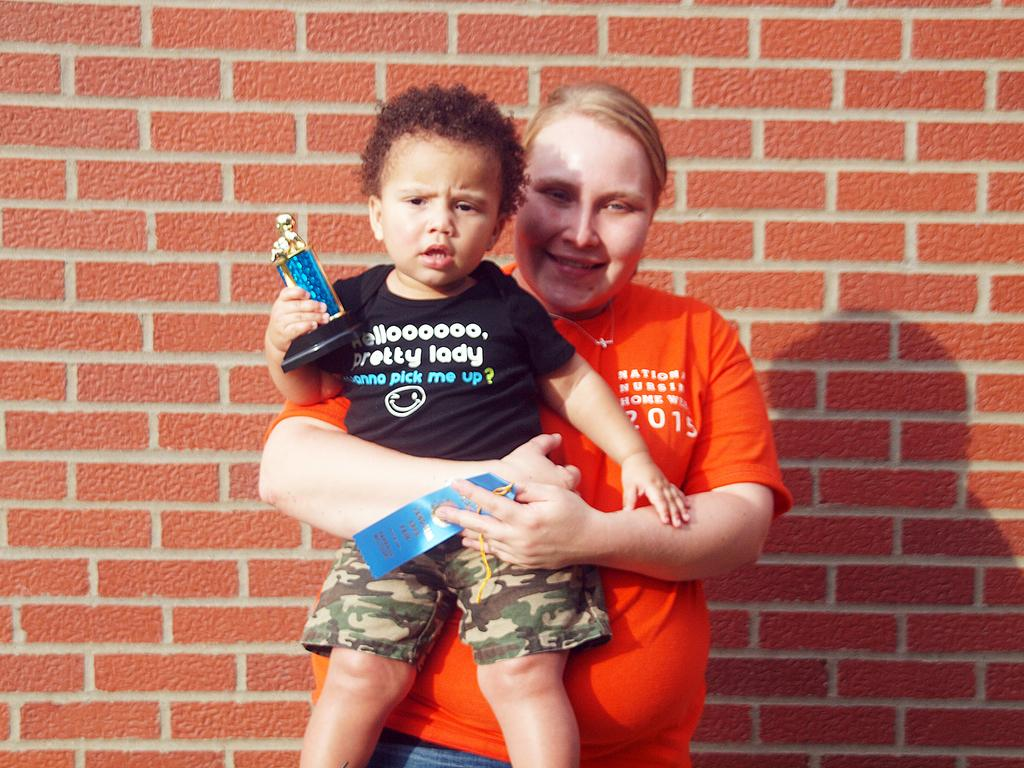What is the main subject of the image? There is a woman standing in the middle of the image. What is the woman doing in the image? The woman is smiling and holding a baby. What can be seen in the background of the image? There is a brick wall in the background of the image. How many beds are visible in the image? There are no beds present in the image. Does the woman in the image express any regret? There is no indication of regret in the woman's expression or actions in the image. 